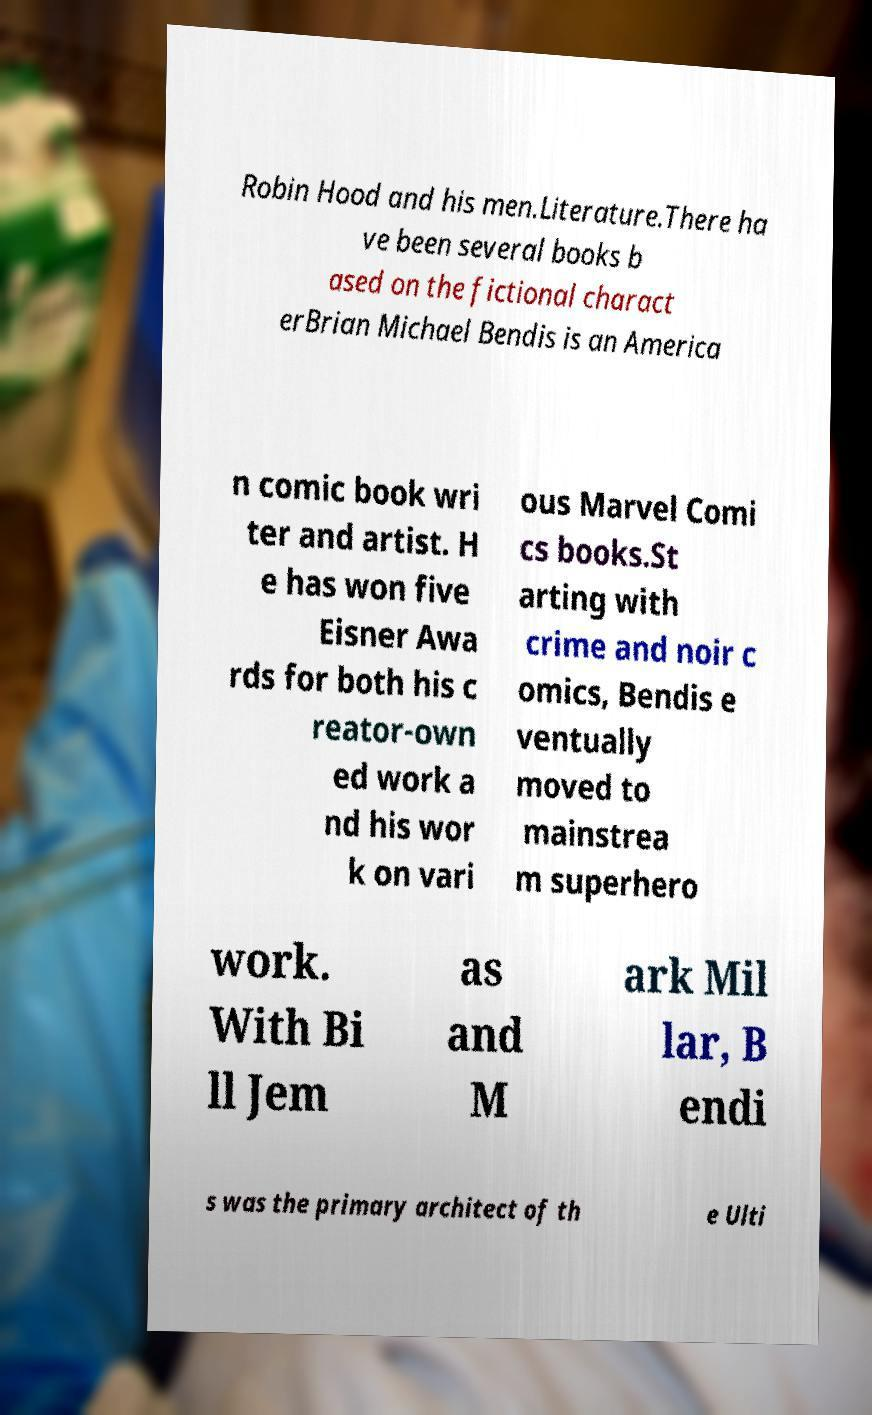Please read and relay the text visible in this image. What does it say? Robin Hood and his men.Literature.There ha ve been several books b ased on the fictional charact erBrian Michael Bendis is an America n comic book wri ter and artist. H e has won five Eisner Awa rds for both his c reator-own ed work a nd his wor k on vari ous Marvel Comi cs books.St arting with crime and noir c omics, Bendis e ventually moved to mainstrea m superhero work. With Bi ll Jem as and M ark Mil lar, B endi s was the primary architect of th e Ulti 